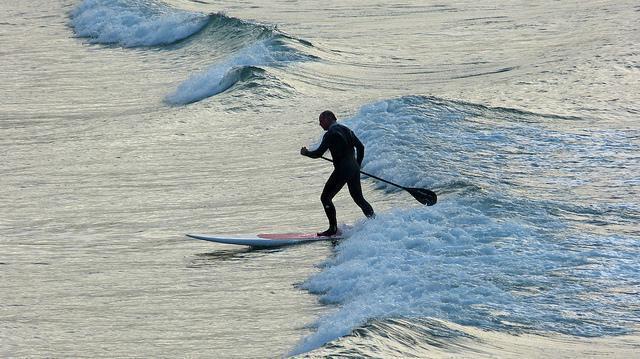How many people are in the picture?
Give a very brief answer. 1. How many green cars in the picture?
Give a very brief answer. 0. 